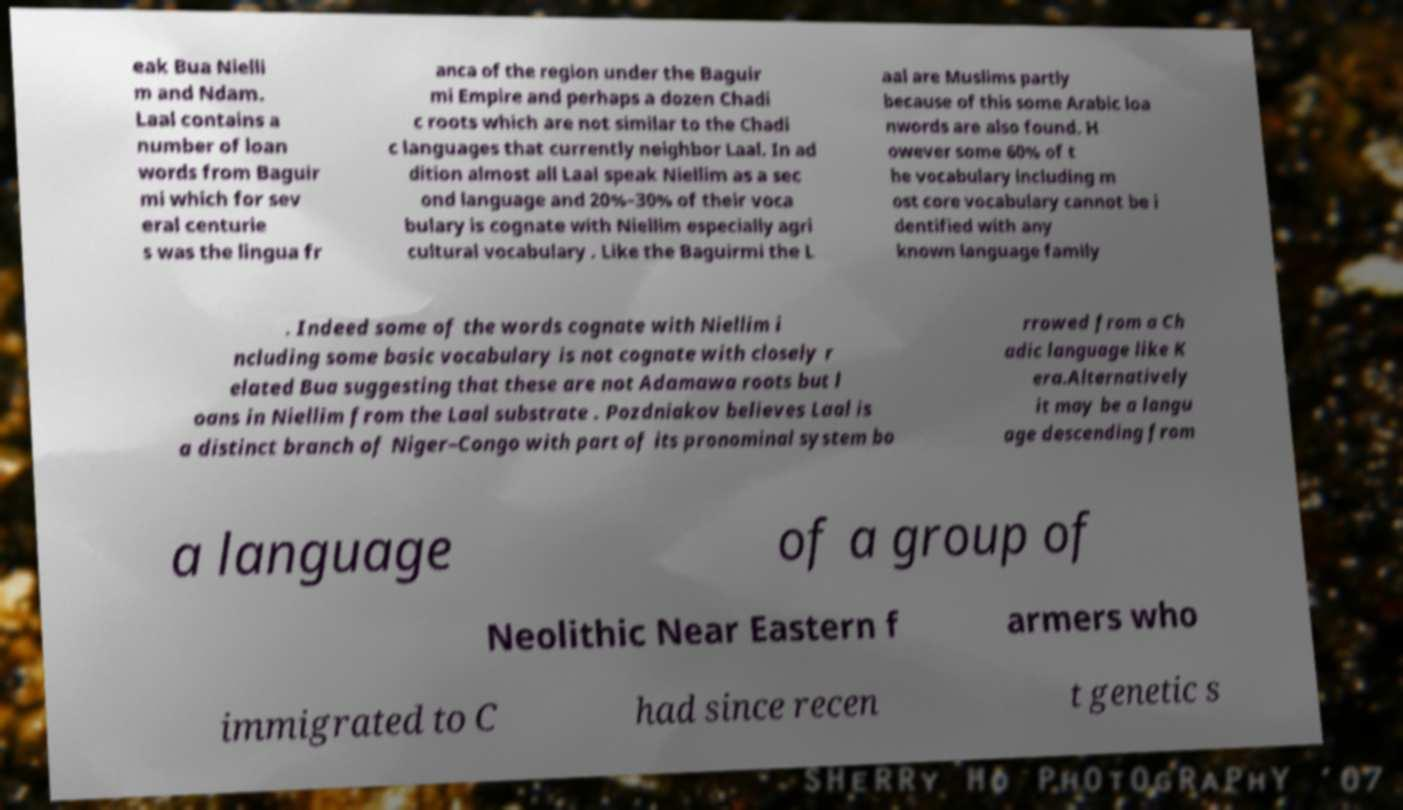Please read and relay the text visible in this image. What does it say? eak Bua Nielli m and Ndam. Laal contains a number of loan words from Baguir mi which for sev eral centurie s was the lingua fr anca of the region under the Baguir mi Empire and perhaps a dozen Chadi c roots which are not similar to the Chadi c languages that currently neighbor Laal. In ad dition almost all Laal speak Niellim as a sec ond language and 20%–30% of their voca bulary is cognate with Niellim especially agri cultural vocabulary . Like the Baguirmi the L aal are Muslims partly because of this some Arabic loa nwords are also found. H owever some 60% of t he vocabulary including m ost core vocabulary cannot be i dentified with any known language family . Indeed some of the words cognate with Niellim i ncluding some basic vocabulary is not cognate with closely r elated Bua suggesting that these are not Adamawa roots but l oans in Niellim from the Laal substrate . Pozdniakov believes Laal is a distinct branch of Niger–Congo with part of its pronominal system bo rrowed from a Ch adic language like K era.Alternatively it may be a langu age descending from a language of a group of Neolithic Near Eastern f armers who immigrated to C had since recen t genetic s 